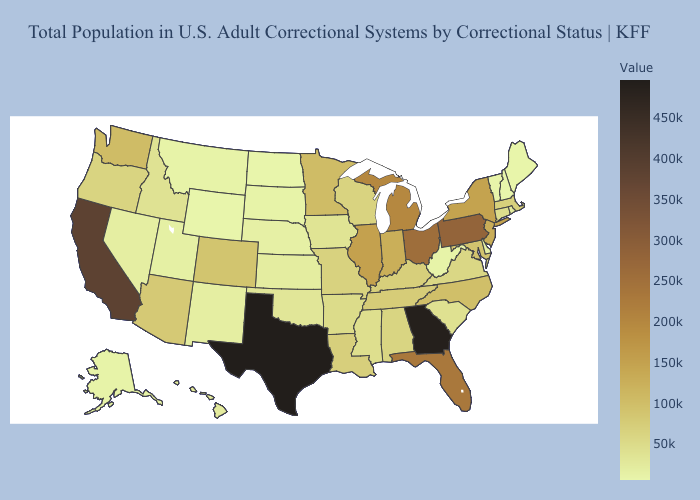Which states have the lowest value in the South?
Quick response, please. West Virginia. Does Vermont have the highest value in the USA?
Answer briefly. No. Does Wyoming have the lowest value in the USA?
Write a very short answer. Yes. Which states have the lowest value in the South?
Write a very short answer. West Virginia. Among the states that border Oregon , does Idaho have the lowest value?
Give a very brief answer. No. 